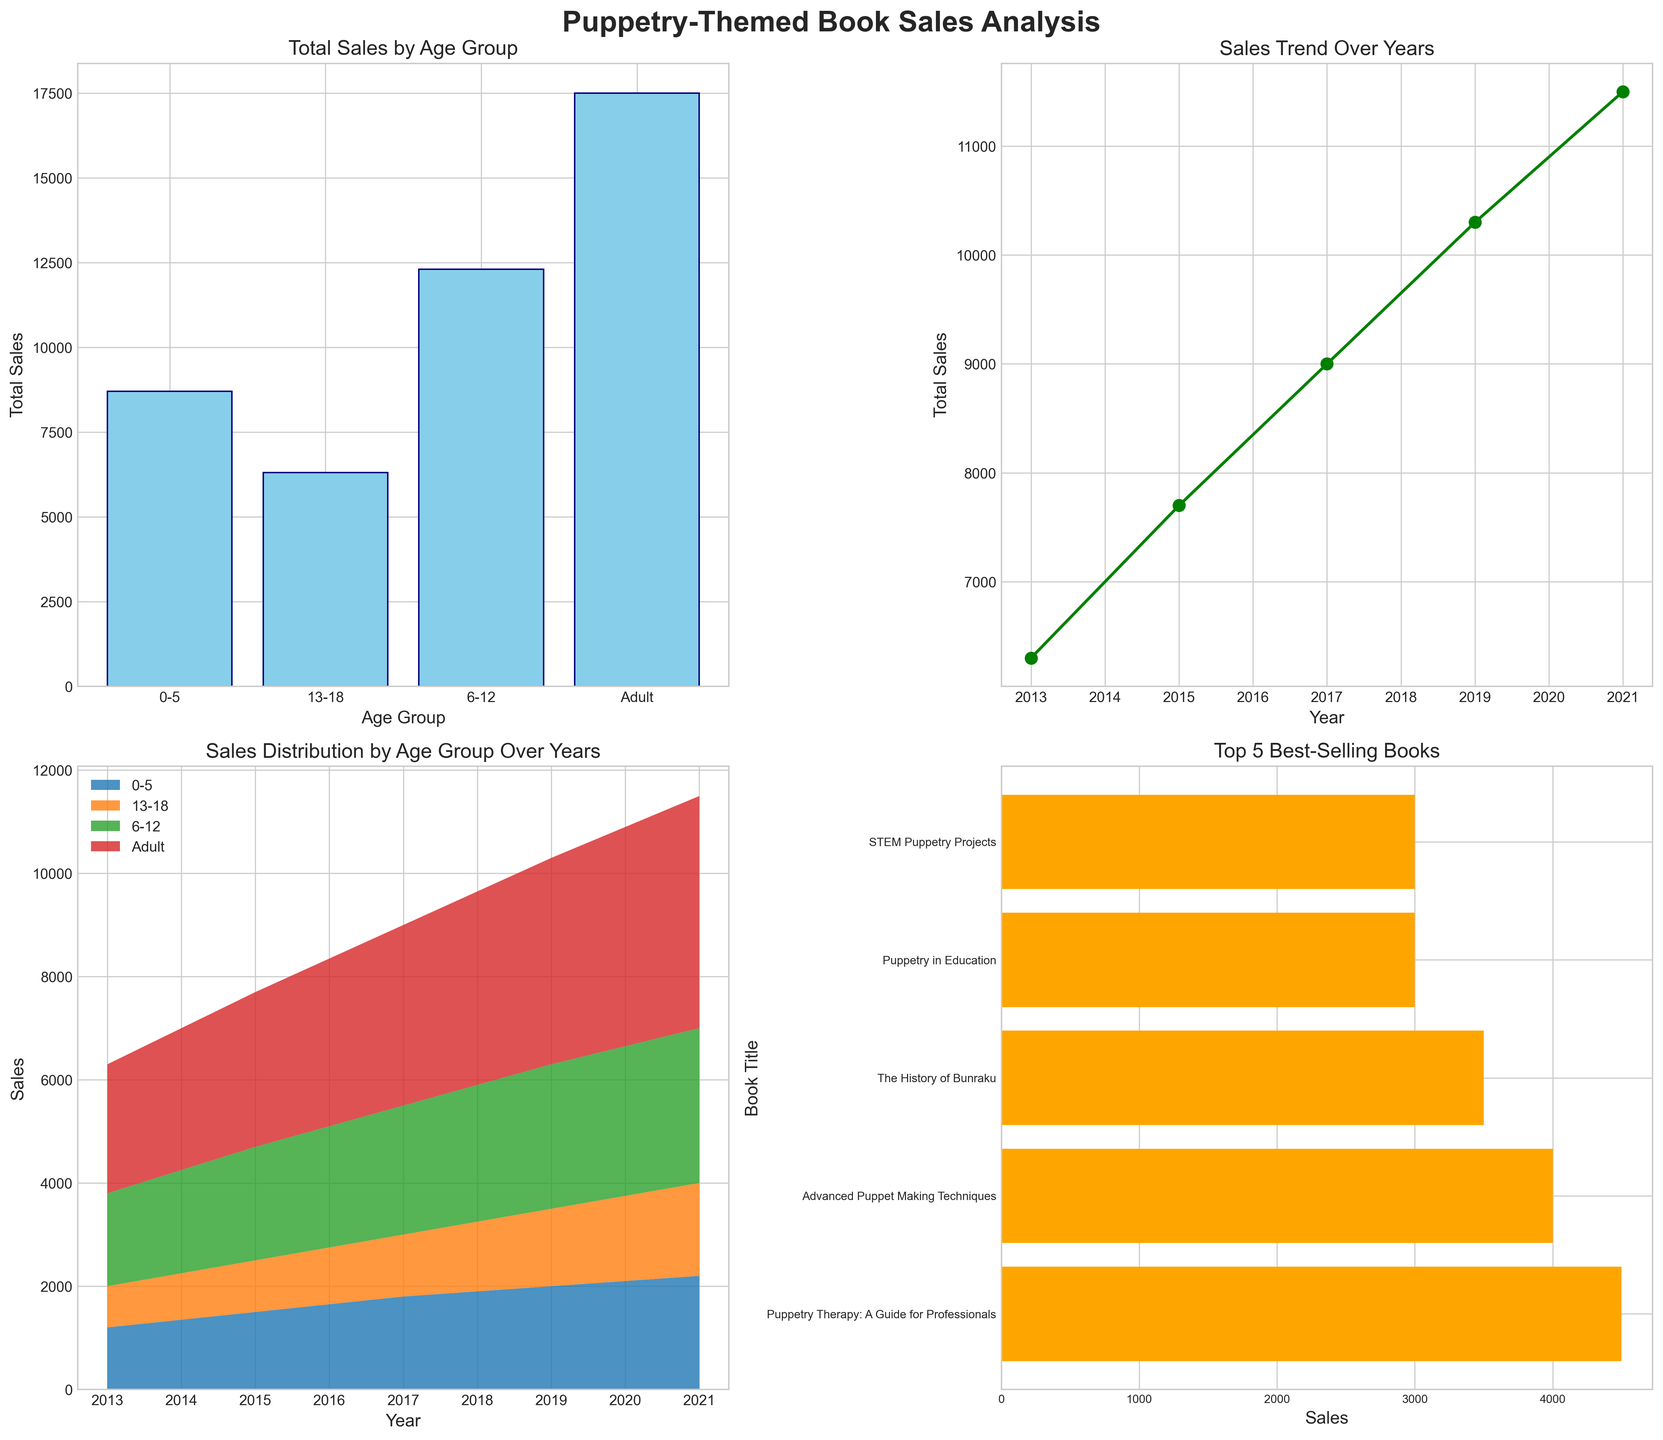What is the total sales amount for the Adult age group across all years? Sum the sales for Adult books from each year: 2500 (2013) + 3000 (2015) + 3500 (2017) + 4000 (2019) + 4500 (2021) = 17500.
Answer: 17500 Which age group has the highest total sales? Compare the total sales across all age groups. The Adult age group has the highest total sales (17500).
Answer: Adult How did total sales trend over the years according to the line plot? The line plot shows total sales increased steadily from 2013 to 2021, with a visible increase every two-year step: 6300 (2013) to 7700 (2015) to 9000 (2017) to 10300 (2019) to 11500 (2021).
Answer: Increasing What was the top-selling puppetry-themed book and its sales figure? Consult the horizontal bar chart. "Puppetry Therapy: A Guide for Professionals" has the highest sales with 4500 units.
Answer: "Puppetry Therapy: A Guide for Professionals", 4500 What year had the highest total sales? Look at the peak in the line plot on the x-axis for year and y-axis for total sales. 2021 had the highest total sales: 11500.
Answer: 2021 Which age group shows the most consistent sales over the years according to the stacked area chart? By visually comparing the even distribution of areas, the 0-5 age group has the most consistent sales due to evenly distributed bands in the chart.
Answer: 0-5 What age group had the greatest increase in sales from 2019 to 2021? Compare the area changes from 2019 to 2021. The 0-5 age group showed a noticeable increase from 2000 to 2200 in the stacked area chart.
Answer: 0-5 Which book had the least sales among the top 5 best-selling books? Find the smallest bar in the horizontal bar chart, which corresponds to "Advanced Puppet Making Techniques" with sales of 4000 units.
Answer: "Advanced Puppet Making Techniques" What type of chart is used to show the total sales by age group? The subplot showing total sales by age group is a vertical bar chart.
Answer: Vertical bar chart 